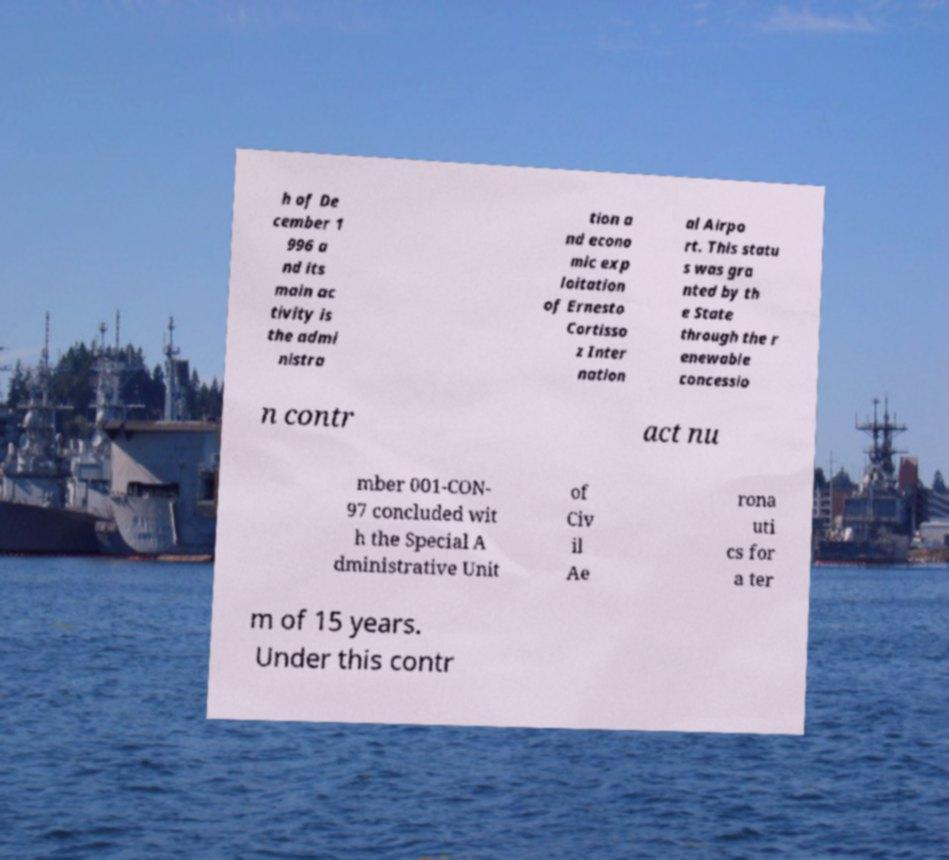Can you accurately transcribe the text from the provided image for me? h of De cember 1 996 a nd its main ac tivity is the admi nistra tion a nd econo mic exp loitation of Ernesto Cortisso z Inter nation al Airpo rt. This statu s was gra nted by th e State through the r enewable concessio n contr act nu mber 001-CON- 97 concluded wit h the Special A dministrative Unit of Civ il Ae rona uti cs for a ter m of 15 years. Under this contr 